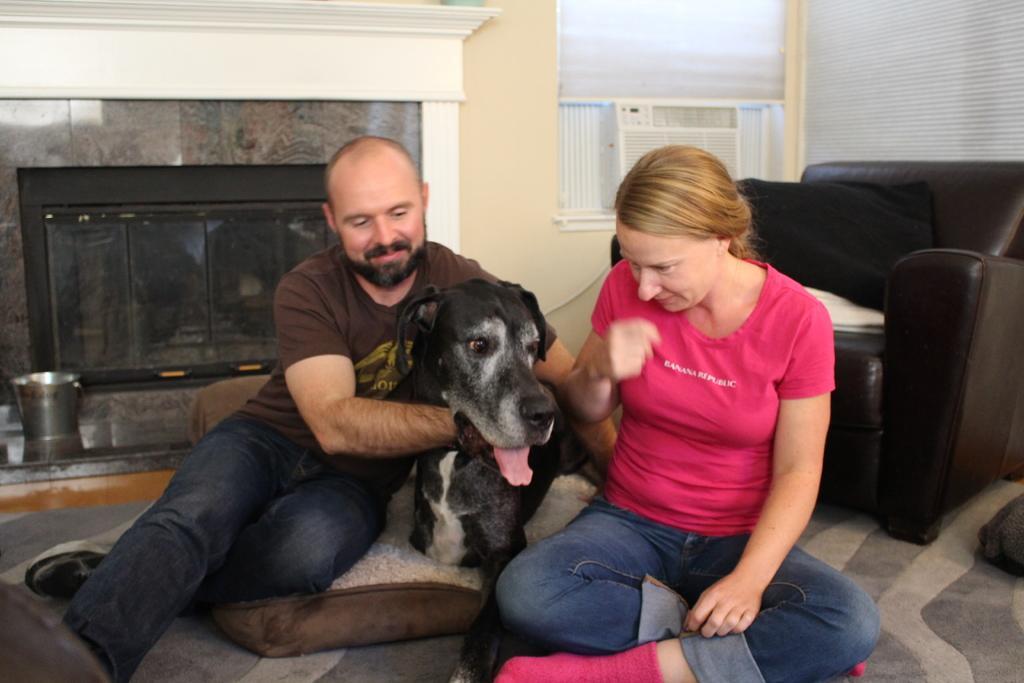In one or two sentences, can you explain what this image depicts? In this picture there is a man and a woman sitting on carpet. There is a dog. There is a sofa and a pillow. There is a bucket and a cloth. 